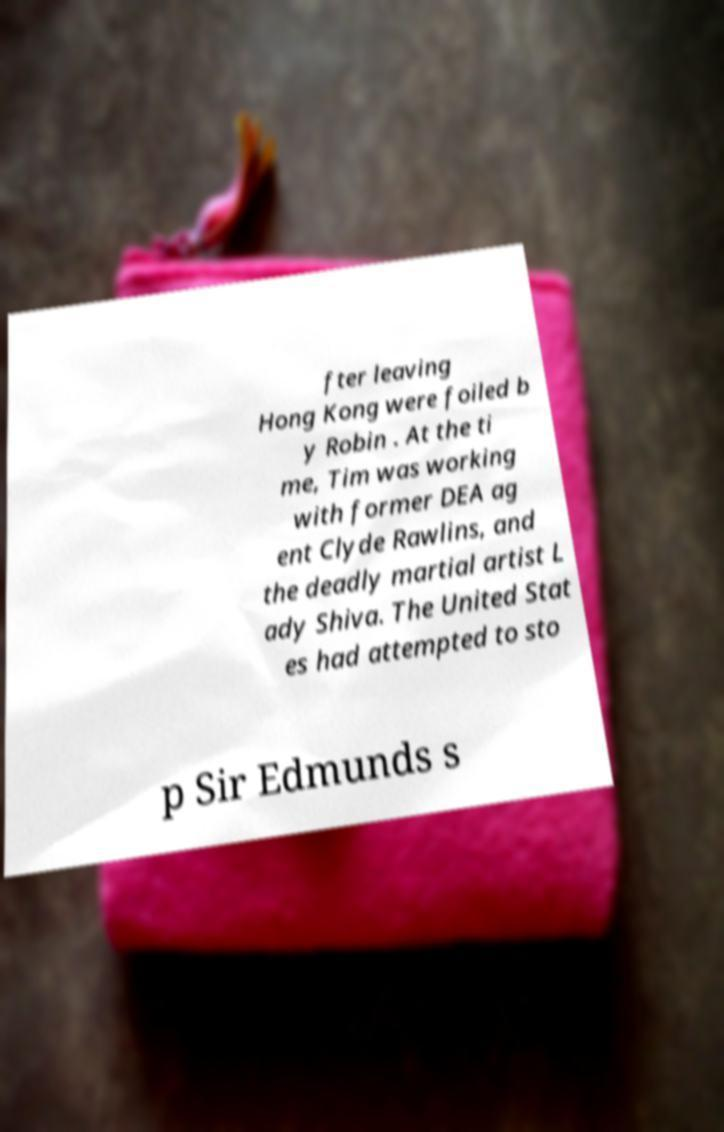Could you extract and type out the text from this image? fter leaving Hong Kong were foiled b y Robin . At the ti me, Tim was working with former DEA ag ent Clyde Rawlins, and the deadly martial artist L ady Shiva. The United Stat es had attempted to sto p Sir Edmunds s 